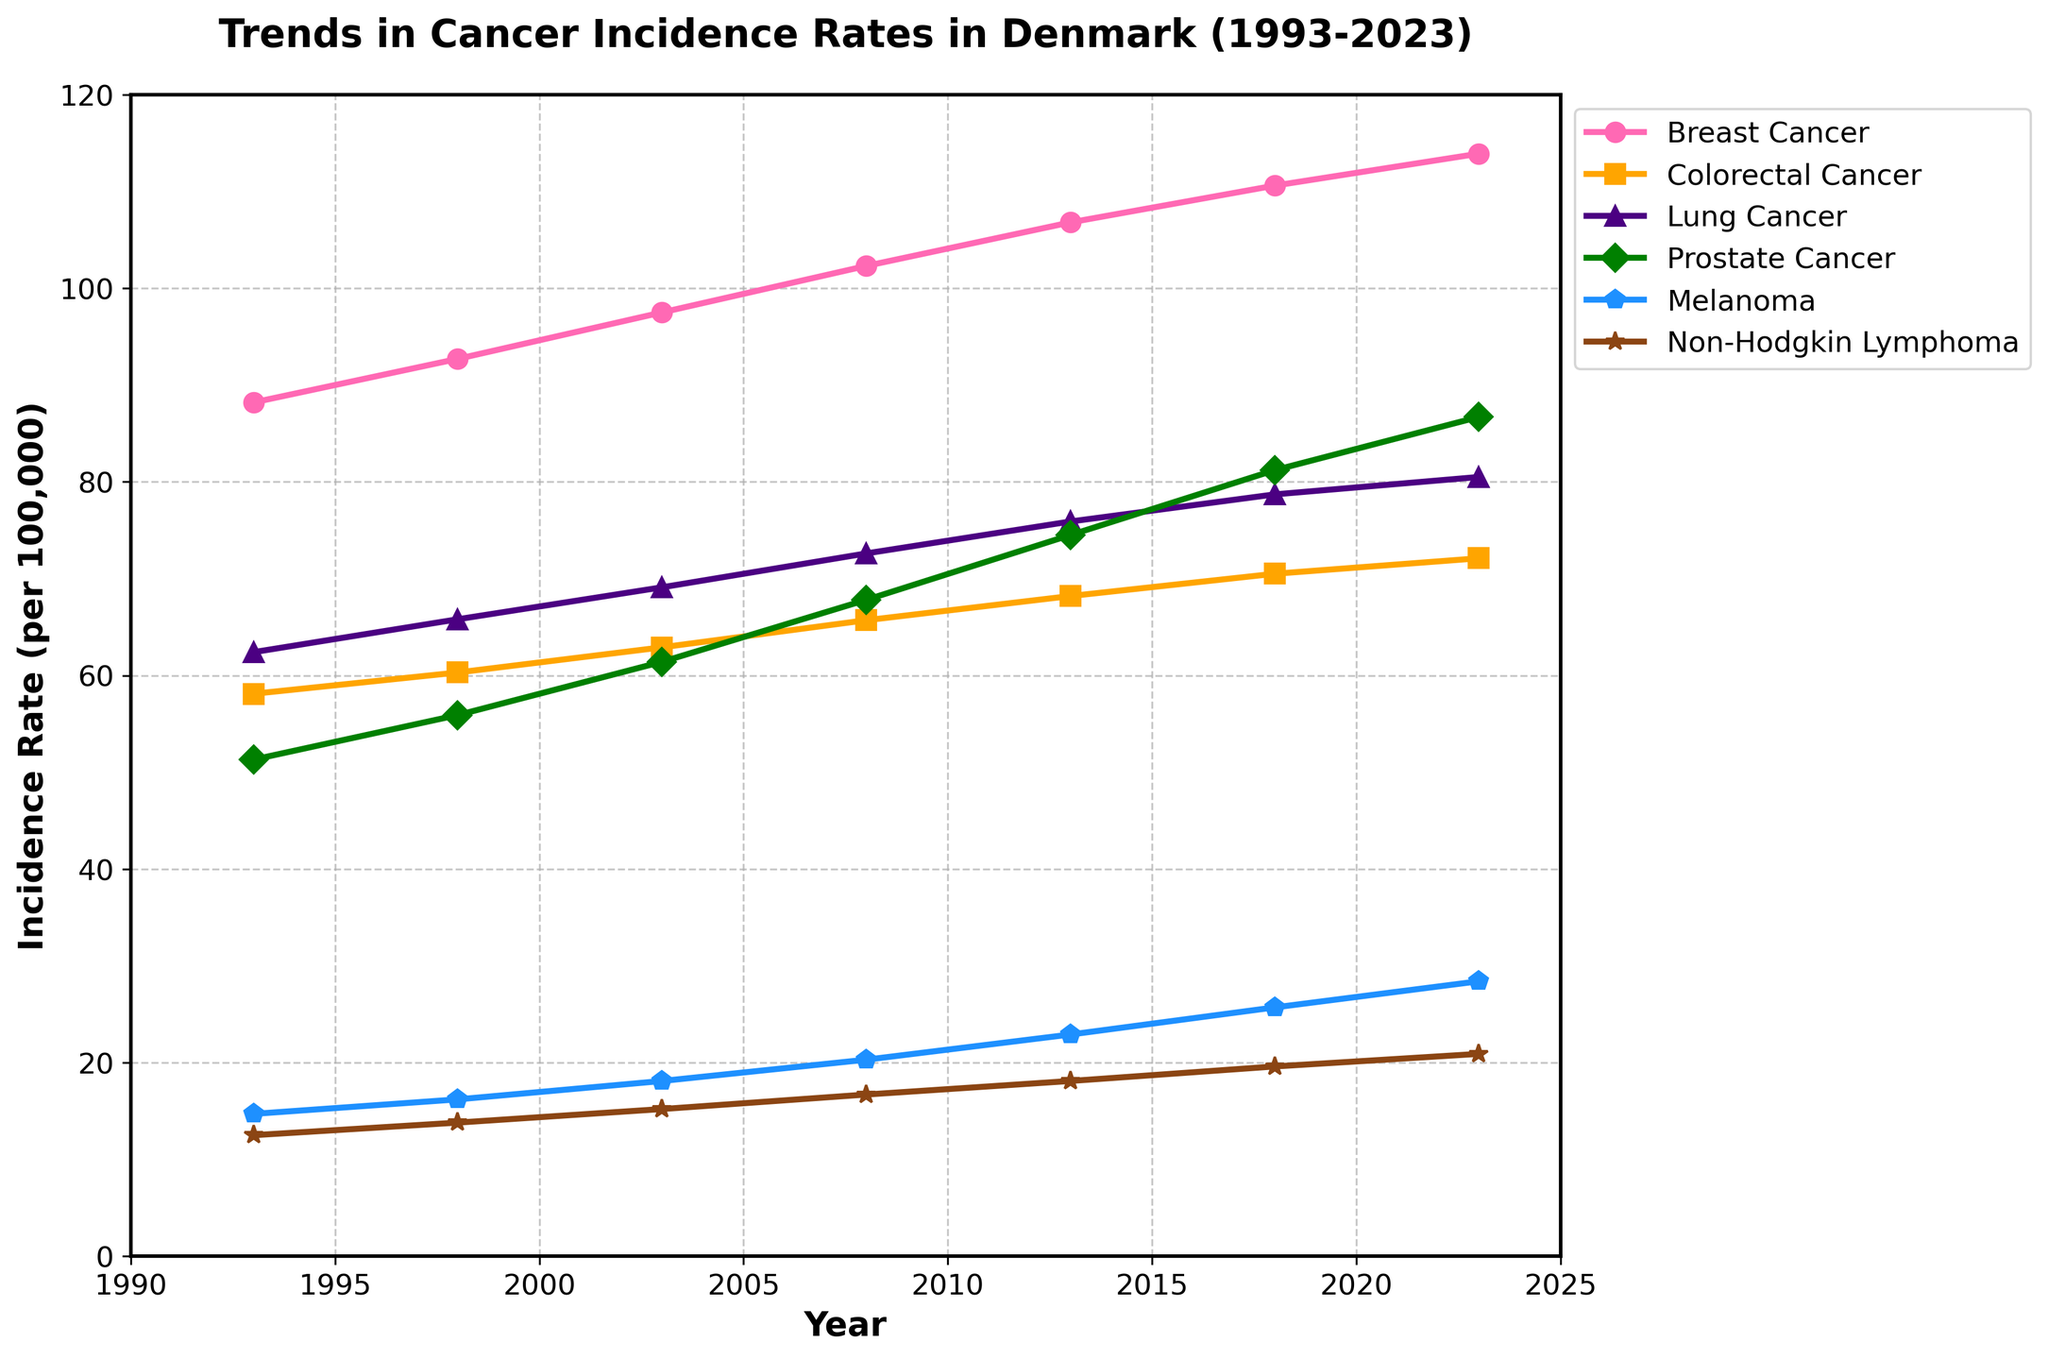What's the difference in incidence rates between Breast Cancer and Lung Cancer in the year 2008? In 2008, the incidence rate for Breast Cancer is 102.3, and for Lung Cancer, it is 72.6. The difference is calculated as 102.3 - 72.6 = 29.7
Answer: 29.7 Which cancer type shows the highest incidence rate in 2023? By looking at the figure, Prostate Cancer has the highest value in 2023 with an incidence rate of 86.7
Answer: Prostate Cancer Has the incidence rate of Non-Hodgkin Lymphoma increased or decreased from 1993 to 2023? The incidence rate of Non-Hodgkin Lymphoma in 1993 is 12.5, and in 2023 it is 20.9. Since 20.9 > 12.5, it has increased
Answer: Increased What is the average incidence rate of Melanoma across all years shown? Sum the incidence rates of Melanoma: 14.7 + 16.2 + 18.1 + 20.3 + 22.9 + 25.7 + 28.4 = 146.3. There are 7 years, so the average is 146.3 / 7 = 20.9
Answer: 20.9 Which cancer type has seen the most significant increase in incidence rate from 1993 to 2023? Compare the increase for each cancer type from 1993 to 2023: Breast Cancer (113.9 - 88.2 = 25.7), Colorectal Cancer (72.1 - 58.1 = 14.0), Lung Cancer (80.5 - 62.4 = 18.1), Prostate Cancer (86.7 - 51.3 = 35.4), Melanoma (28.4 - 14.7 = 13.7), Non-Hodgkin Lymphoma (20.9 - 12.5 = 8.4). Prostate Cancer shows the most significant increase of 35.4
Answer: Prostate Cancer Rank the cancer types by their incidence rates in 1998 from highest to lowest. The incidence rates in 1998 are: Breast Cancer (92.7), Colorectal Cancer (60.3), Lung Cancer (65.8), Prostate Cancer (55.9), Melanoma (16.2), Non-Hodgkin Lymphoma (13.8). Ranks: 1) Breast Cancer, 2) Lung Cancer, 3) Colorectal Cancer, 4) Prostate Cancer, 5) Melanoma, 6) Non-Hodgkin Lymphoma
Answer: 1) Breast Cancer, 2) Lung Cancer, 3) Colorectal Cancer, 4) Prostate Cancer, 5) Melanoma, 6) Non-Hodgkin Lymphoma What's the difference in the incidence rate for Prostate Cancer between the years 2003 and 2013? In 2003, the incidence rate for Prostate Cancer is 61.4, and in 2013 it is 74.5. The difference is 74.5 - 61.4 = 13.1
Answer: 13.1 